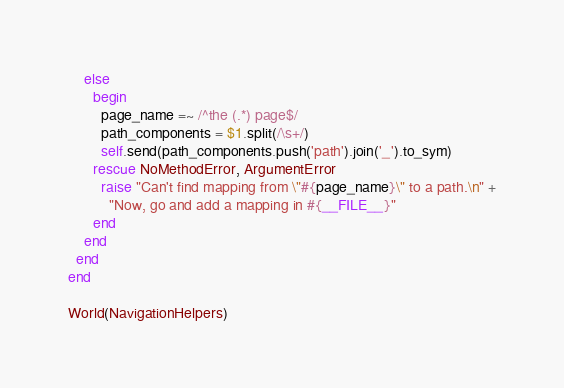<code> <loc_0><loc_0><loc_500><loc_500><_Ruby_>
    else
      begin
        page_name =~ /^the (.*) page$/
        path_components = $1.split(/\s+/)
        self.send(path_components.push('path').join('_').to_sym)
      rescue NoMethodError, ArgumentError
        raise "Can't find mapping from \"#{page_name}\" to a path.\n" +
          "Now, go and add a mapping in #{__FILE__}"
      end
    end
  end
end

World(NavigationHelpers)</code> 